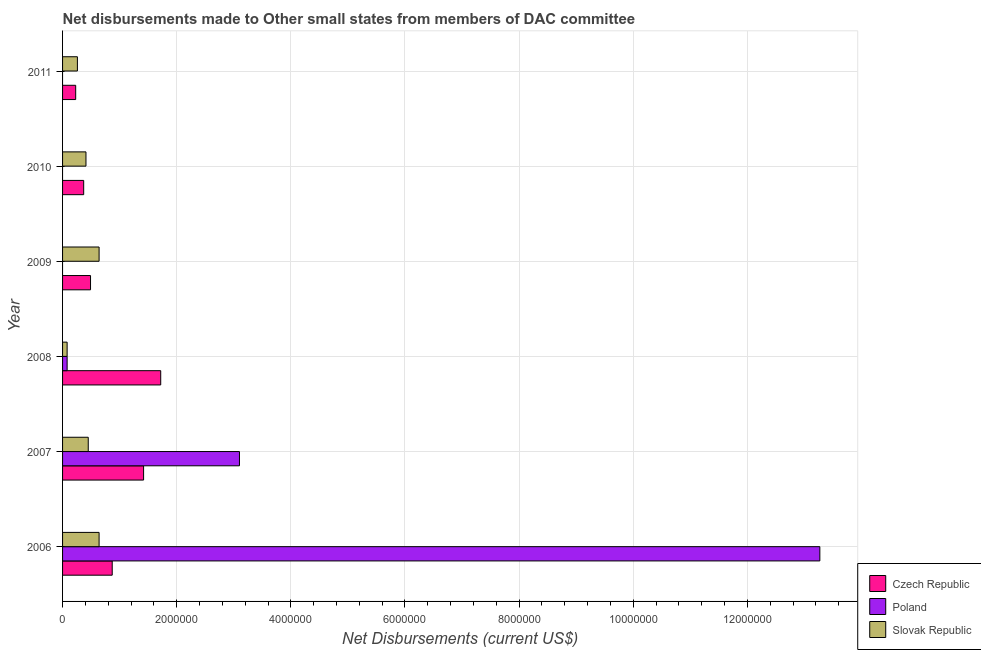How many different coloured bars are there?
Your answer should be compact. 3. Are the number of bars per tick equal to the number of legend labels?
Provide a succinct answer. No. Are the number of bars on each tick of the Y-axis equal?
Keep it short and to the point. No. What is the label of the 2nd group of bars from the top?
Give a very brief answer. 2010. In how many cases, is the number of bars for a given year not equal to the number of legend labels?
Your answer should be compact. 3. What is the net disbursements made by slovak republic in 2010?
Your answer should be compact. 4.10e+05. Across all years, what is the maximum net disbursements made by czech republic?
Give a very brief answer. 1.72e+06. Across all years, what is the minimum net disbursements made by slovak republic?
Provide a short and direct response. 8.00e+04. What is the total net disbursements made by czech republic in the graph?
Your response must be concise. 5.10e+06. What is the difference between the net disbursements made by slovak republic in 2008 and that in 2010?
Offer a very short reply. -3.30e+05. What is the difference between the net disbursements made by czech republic in 2010 and the net disbursements made by poland in 2009?
Your response must be concise. 3.70e+05. What is the average net disbursements made by poland per year?
Make the answer very short. 2.74e+06. In the year 2009, what is the difference between the net disbursements made by slovak republic and net disbursements made by czech republic?
Ensure brevity in your answer.  1.50e+05. In how many years, is the net disbursements made by slovak republic greater than 8800000 US$?
Offer a very short reply. 0. What is the ratio of the net disbursements made by czech republic in 2006 to that in 2011?
Offer a terse response. 3.78. What is the difference between the highest and the second highest net disbursements made by czech republic?
Your answer should be very brief. 3.00e+05. What is the difference between the highest and the lowest net disbursements made by czech republic?
Your answer should be compact. 1.49e+06. Is the sum of the net disbursements made by czech republic in 2007 and 2008 greater than the maximum net disbursements made by poland across all years?
Ensure brevity in your answer.  No. How many bars are there?
Provide a succinct answer. 15. Are all the bars in the graph horizontal?
Make the answer very short. Yes. How many years are there in the graph?
Give a very brief answer. 6. What is the difference between two consecutive major ticks on the X-axis?
Your response must be concise. 2.00e+06. Does the graph contain any zero values?
Offer a terse response. Yes. Does the graph contain grids?
Your answer should be very brief. Yes. How many legend labels are there?
Make the answer very short. 3. How are the legend labels stacked?
Provide a short and direct response. Vertical. What is the title of the graph?
Your answer should be very brief. Net disbursements made to Other small states from members of DAC committee. What is the label or title of the X-axis?
Keep it short and to the point. Net Disbursements (current US$). What is the Net Disbursements (current US$) of Czech Republic in 2006?
Your response must be concise. 8.70e+05. What is the Net Disbursements (current US$) of Poland in 2006?
Provide a succinct answer. 1.33e+07. What is the Net Disbursements (current US$) of Slovak Republic in 2006?
Make the answer very short. 6.40e+05. What is the Net Disbursements (current US$) of Czech Republic in 2007?
Provide a short and direct response. 1.42e+06. What is the Net Disbursements (current US$) of Poland in 2007?
Make the answer very short. 3.10e+06. What is the Net Disbursements (current US$) in Czech Republic in 2008?
Offer a very short reply. 1.72e+06. What is the Net Disbursements (current US$) of Czech Republic in 2009?
Give a very brief answer. 4.90e+05. What is the Net Disbursements (current US$) in Slovak Republic in 2009?
Offer a very short reply. 6.40e+05. What is the Net Disbursements (current US$) of Poland in 2010?
Offer a terse response. 0. What is the Net Disbursements (current US$) of Slovak Republic in 2010?
Offer a terse response. 4.10e+05. What is the Net Disbursements (current US$) of Czech Republic in 2011?
Give a very brief answer. 2.30e+05. Across all years, what is the maximum Net Disbursements (current US$) of Czech Republic?
Your answer should be compact. 1.72e+06. Across all years, what is the maximum Net Disbursements (current US$) in Poland?
Ensure brevity in your answer.  1.33e+07. Across all years, what is the maximum Net Disbursements (current US$) in Slovak Republic?
Keep it short and to the point. 6.40e+05. Across all years, what is the minimum Net Disbursements (current US$) of Czech Republic?
Offer a very short reply. 2.30e+05. What is the total Net Disbursements (current US$) of Czech Republic in the graph?
Your answer should be very brief. 5.10e+06. What is the total Net Disbursements (current US$) in Poland in the graph?
Offer a very short reply. 1.64e+07. What is the total Net Disbursements (current US$) of Slovak Republic in the graph?
Your answer should be very brief. 2.48e+06. What is the difference between the Net Disbursements (current US$) of Czech Republic in 2006 and that in 2007?
Ensure brevity in your answer.  -5.50e+05. What is the difference between the Net Disbursements (current US$) of Poland in 2006 and that in 2007?
Your answer should be compact. 1.02e+07. What is the difference between the Net Disbursements (current US$) in Slovak Republic in 2006 and that in 2007?
Offer a terse response. 1.90e+05. What is the difference between the Net Disbursements (current US$) in Czech Republic in 2006 and that in 2008?
Provide a short and direct response. -8.50e+05. What is the difference between the Net Disbursements (current US$) of Poland in 2006 and that in 2008?
Keep it short and to the point. 1.32e+07. What is the difference between the Net Disbursements (current US$) of Slovak Republic in 2006 and that in 2008?
Offer a terse response. 5.60e+05. What is the difference between the Net Disbursements (current US$) in Czech Republic in 2006 and that in 2009?
Keep it short and to the point. 3.80e+05. What is the difference between the Net Disbursements (current US$) of Slovak Republic in 2006 and that in 2009?
Make the answer very short. 0. What is the difference between the Net Disbursements (current US$) in Czech Republic in 2006 and that in 2011?
Give a very brief answer. 6.40e+05. What is the difference between the Net Disbursements (current US$) of Slovak Republic in 2006 and that in 2011?
Your answer should be compact. 3.80e+05. What is the difference between the Net Disbursements (current US$) in Czech Republic in 2007 and that in 2008?
Offer a terse response. -3.00e+05. What is the difference between the Net Disbursements (current US$) in Poland in 2007 and that in 2008?
Provide a short and direct response. 3.02e+06. What is the difference between the Net Disbursements (current US$) of Czech Republic in 2007 and that in 2009?
Ensure brevity in your answer.  9.30e+05. What is the difference between the Net Disbursements (current US$) in Slovak Republic in 2007 and that in 2009?
Offer a very short reply. -1.90e+05. What is the difference between the Net Disbursements (current US$) in Czech Republic in 2007 and that in 2010?
Offer a terse response. 1.05e+06. What is the difference between the Net Disbursements (current US$) of Slovak Republic in 2007 and that in 2010?
Your response must be concise. 4.00e+04. What is the difference between the Net Disbursements (current US$) in Czech Republic in 2007 and that in 2011?
Keep it short and to the point. 1.19e+06. What is the difference between the Net Disbursements (current US$) in Czech Republic in 2008 and that in 2009?
Keep it short and to the point. 1.23e+06. What is the difference between the Net Disbursements (current US$) of Slovak Republic in 2008 and that in 2009?
Offer a very short reply. -5.60e+05. What is the difference between the Net Disbursements (current US$) of Czech Republic in 2008 and that in 2010?
Your answer should be compact. 1.35e+06. What is the difference between the Net Disbursements (current US$) of Slovak Republic in 2008 and that in 2010?
Offer a very short reply. -3.30e+05. What is the difference between the Net Disbursements (current US$) of Czech Republic in 2008 and that in 2011?
Give a very brief answer. 1.49e+06. What is the difference between the Net Disbursements (current US$) of Czech Republic in 2009 and that in 2010?
Provide a short and direct response. 1.20e+05. What is the difference between the Net Disbursements (current US$) of Slovak Republic in 2009 and that in 2010?
Your answer should be very brief. 2.30e+05. What is the difference between the Net Disbursements (current US$) in Czech Republic in 2009 and that in 2011?
Your answer should be very brief. 2.60e+05. What is the difference between the Net Disbursements (current US$) in Slovak Republic in 2009 and that in 2011?
Your response must be concise. 3.80e+05. What is the difference between the Net Disbursements (current US$) of Czech Republic in 2010 and that in 2011?
Provide a short and direct response. 1.40e+05. What is the difference between the Net Disbursements (current US$) in Czech Republic in 2006 and the Net Disbursements (current US$) in Poland in 2007?
Offer a very short reply. -2.23e+06. What is the difference between the Net Disbursements (current US$) of Czech Republic in 2006 and the Net Disbursements (current US$) of Slovak Republic in 2007?
Ensure brevity in your answer.  4.20e+05. What is the difference between the Net Disbursements (current US$) of Poland in 2006 and the Net Disbursements (current US$) of Slovak Republic in 2007?
Give a very brief answer. 1.28e+07. What is the difference between the Net Disbursements (current US$) of Czech Republic in 2006 and the Net Disbursements (current US$) of Poland in 2008?
Provide a short and direct response. 7.90e+05. What is the difference between the Net Disbursements (current US$) of Czech Republic in 2006 and the Net Disbursements (current US$) of Slovak Republic in 2008?
Ensure brevity in your answer.  7.90e+05. What is the difference between the Net Disbursements (current US$) in Poland in 2006 and the Net Disbursements (current US$) in Slovak Republic in 2008?
Provide a short and direct response. 1.32e+07. What is the difference between the Net Disbursements (current US$) of Czech Republic in 2006 and the Net Disbursements (current US$) of Slovak Republic in 2009?
Your answer should be very brief. 2.30e+05. What is the difference between the Net Disbursements (current US$) of Poland in 2006 and the Net Disbursements (current US$) of Slovak Republic in 2009?
Keep it short and to the point. 1.26e+07. What is the difference between the Net Disbursements (current US$) in Czech Republic in 2006 and the Net Disbursements (current US$) in Slovak Republic in 2010?
Make the answer very short. 4.60e+05. What is the difference between the Net Disbursements (current US$) of Poland in 2006 and the Net Disbursements (current US$) of Slovak Republic in 2010?
Make the answer very short. 1.29e+07. What is the difference between the Net Disbursements (current US$) of Poland in 2006 and the Net Disbursements (current US$) of Slovak Republic in 2011?
Your response must be concise. 1.30e+07. What is the difference between the Net Disbursements (current US$) in Czech Republic in 2007 and the Net Disbursements (current US$) in Poland in 2008?
Offer a very short reply. 1.34e+06. What is the difference between the Net Disbursements (current US$) in Czech Republic in 2007 and the Net Disbursements (current US$) in Slovak Republic in 2008?
Offer a terse response. 1.34e+06. What is the difference between the Net Disbursements (current US$) of Poland in 2007 and the Net Disbursements (current US$) of Slovak Republic in 2008?
Make the answer very short. 3.02e+06. What is the difference between the Net Disbursements (current US$) of Czech Republic in 2007 and the Net Disbursements (current US$) of Slovak Republic in 2009?
Offer a very short reply. 7.80e+05. What is the difference between the Net Disbursements (current US$) of Poland in 2007 and the Net Disbursements (current US$) of Slovak Republic in 2009?
Give a very brief answer. 2.46e+06. What is the difference between the Net Disbursements (current US$) in Czech Republic in 2007 and the Net Disbursements (current US$) in Slovak Republic in 2010?
Provide a succinct answer. 1.01e+06. What is the difference between the Net Disbursements (current US$) in Poland in 2007 and the Net Disbursements (current US$) in Slovak Republic in 2010?
Offer a terse response. 2.69e+06. What is the difference between the Net Disbursements (current US$) in Czech Republic in 2007 and the Net Disbursements (current US$) in Slovak Republic in 2011?
Ensure brevity in your answer.  1.16e+06. What is the difference between the Net Disbursements (current US$) in Poland in 2007 and the Net Disbursements (current US$) in Slovak Republic in 2011?
Offer a very short reply. 2.84e+06. What is the difference between the Net Disbursements (current US$) of Czech Republic in 2008 and the Net Disbursements (current US$) of Slovak Republic in 2009?
Ensure brevity in your answer.  1.08e+06. What is the difference between the Net Disbursements (current US$) in Poland in 2008 and the Net Disbursements (current US$) in Slovak Republic in 2009?
Your answer should be very brief. -5.60e+05. What is the difference between the Net Disbursements (current US$) of Czech Republic in 2008 and the Net Disbursements (current US$) of Slovak Republic in 2010?
Offer a terse response. 1.31e+06. What is the difference between the Net Disbursements (current US$) in Poland in 2008 and the Net Disbursements (current US$) in Slovak Republic in 2010?
Your answer should be compact. -3.30e+05. What is the difference between the Net Disbursements (current US$) in Czech Republic in 2008 and the Net Disbursements (current US$) in Slovak Republic in 2011?
Offer a terse response. 1.46e+06. What is the difference between the Net Disbursements (current US$) of Poland in 2008 and the Net Disbursements (current US$) of Slovak Republic in 2011?
Offer a very short reply. -1.80e+05. What is the difference between the Net Disbursements (current US$) of Czech Republic in 2009 and the Net Disbursements (current US$) of Slovak Republic in 2010?
Offer a very short reply. 8.00e+04. What is the average Net Disbursements (current US$) in Czech Republic per year?
Offer a very short reply. 8.50e+05. What is the average Net Disbursements (current US$) of Poland per year?
Offer a terse response. 2.74e+06. What is the average Net Disbursements (current US$) of Slovak Republic per year?
Your answer should be compact. 4.13e+05. In the year 2006, what is the difference between the Net Disbursements (current US$) in Czech Republic and Net Disbursements (current US$) in Poland?
Your response must be concise. -1.24e+07. In the year 2006, what is the difference between the Net Disbursements (current US$) in Czech Republic and Net Disbursements (current US$) in Slovak Republic?
Offer a very short reply. 2.30e+05. In the year 2006, what is the difference between the Net Disbursements (current US$) in Poland and Net Disbursements (current US$) in Slovak Republic?
Your answer should be very brief. 1.26e+07. In the year 2007, what is the difference between the Net Disbursements (current US$) in Czech Republic and Net Disbursements (current US$) in Poland?
Provide a succinct answer. -1.68e+06. In the year 2007, what is the difference between the Net Disbursements (current US$) of Czech Republic and Net Disbursements (current US$) of Slovak Republic?
Ensure brevity in your answer.  9.70e+05. In the year 2007, what is the difference between the Net Disbursements (current US$) in Poland and Net Disbursements (current US$) in Slovak Republic?
Provide a short and direct response. 2.65e+06. In the year 2008, what is the difference between the Net Disbursements (current US$) in Czech Republic and Net Disbursements (current US$) in Poland?
Offer a very short reply. 1.64e+06. In the year 2008, what is the difference between the Net Disbursements (current US$) in Czech Republic and Net Disbursements (current US$) in Slovak Republic?
Keep it short and to the point. 1.64e+06. In the year 2009, what is the difference between the Net Disbursements (current US$) of Czech Republic and Net Disbursements (current US$) of Slovak Republic?
Your answer should be very brief. -1.50e+05. In the year 2011, what is the difference between the Net Disbursements (current US$) in Czech Republic and Net Disbursements (current US$) in Slovak Republic?
Your response must be concise. -3.00e+04. What is the ratio of the Net Disbursements (current US$) of Czech Republic in 2006 to that in 2007?
Your answer should be compact. 0.61. What is the ratio of the Net Disbursements (current US$) of Poland in 2006 to that in 2007?
Your response must be concise. 4.28. What is the ratio of the Net Disbursements (current US$) of Slovak Republic in 2006 to that in 2007?
Make the answer very short. 1.42. What is the ratio of the Net Disbursements (current US$) of Czech Republic in 2006 to that in 2008?
Provide a succinct answer. 0.51. What is the ratio of the Net Disbursements (current US$) in Poland in 2006 to that in 2008?
Your response must be concise. 165.88. What is the ratio of the Net Disbursements (current US$) in Slovak Republic in 2006 to that in 2008?
Provide a succinct answer. 8. What is the ratio of the Net Disbursements (current US$) in Czech Republic in 2006 to that in 2009?
Provide a succinct answer. 1.78. What is the ratio of the Net Disbursements (current US$) of Slovak Republic in 2006 to that in 2009?
Provide a short and direct response. 1. What is the ratio of the Net Disbursements (current US$) of Czech Republic in 2006 to that in 2010?
Offer a very short reply. 2.35. What is the ratio of the Net Disbursements (current US$) in Slovak Republic in 2006 to that in 2010?
Your response must be concise. 1.56. What is the ratio of the Net Disbursements (current US$) in Czech Republic in 2006 to that in 2011?
Give a very brief answer. 3.78. What is the ratio of the Net Disbursements (current US$) in Slovak Republic in 2006 to that in 2011?
Your answer should be compact. 2.46. What is the ratio of the Net Disbursements (current US$) of Czech Republic in 2007 to that in 2008?
Provide a succinct answer. 0.83. What is the ratio of the Net Disbursements (current US$) in Poland in 2007 to that in 2008?
Your answer should be very brief. 38.75. What is the ratio of the Net Disbursements (current US$) of Slovak Republic in 2007 to that in 2008?
Your response must be concise. 5.62. What is the ratio of the Net Disbursements (current US$) of Czech Republic in 2007 to that in 2009?
Offer a terse response. 2.9. What is the ratio of the Net Disbursements (current US$) of Slovak Republic in 2007 to that in 2009?
Keep it short and to the point. 0.7. What is the ratio of the Net Disbursements (current US$) of Czech Republic in 2007 to that in 2010?
Your answer should be very brief. 3.84. What is the ratio of the Net Disbursements (current US$) in Slovak Republic in 2007 to that in 2010?
Provide a short and direct response. 1.1. What is the ratio of the Net Disbursements (current US$) of Czech Republic in 2007 to that in 2011?
Provide a succinct answer. 6.17. What is the ratio of the Net Disbursements (current US$) in Slovak Republic in 2007 to that in 2011?
Provide a short and direct response. 1.73. What is the ratio of the Net Disbursements (current US$) in Czech Republic in 2008 to that in 2009?
Your response must be concise. 3.51. What is the ratio of the Net Disbursements (current US$) of Slovak Republic in 2008 to that in 2009?
Your answer should be very brief. 0.12. What is the ratio of the Net Disbursements (current US$) of Czech Republic in 2008 to that in 2010?
Keep it short and to the point. 4.65. What is the ratio of the Net Disbursements (current US$) of Slovak Republic in 2008 to that in 2010?
Your answer should be very brief. 0.2. What is the ratio of the Net Disbursements (current US$) of Czech Republic in 2008 to that in 2011?
Your response must be concise. 7.48. What is the ratio of the Net Disbursements (current US$) of Slovak Republic in 2008 to that in 2011?
Offer a very short reply. 0.31. What is the ratio of the Net Disbursements (current US$) in Czech Republic in 2009 to that in 2010?
Keep it short and to the point. 1.32. What is the ratio of the Net Disbursements (current US$) of Slovak Republic in 2009 to that in 2010?
Provide a short and direct response. 1.56. What is the ratio of the Net Disbursements (current US$) of Czech Republic in 2009 to that in 2011?
Your answer should be very brief. 2.13. What is the ratio of the Net Disbursements (current US$) of Slovak Republic in 2009 to that in 2011?
Keep it short and to the point. 2.46. What is the ratio of the Net Disbursements (current US$) in Czech Republic in 2010 to that in 2011?
Provide a succinct answer. 1.61. What is the ratio of the Net Disbursements (current US$) of Slovak Republic in 2010 to that in 2011?
Provide a short and direct response. 1.58. What is the difference between the highest and the second highest Net Disbursements (current US$) in Poland?
Your answer should be compact. 1.02e+07. What is the difference between the highest and the second highest Net Disbursements (current US$) of Slovak Republic?
Your response must be concise. 0. What is the difference between the highest and the lowest Net Disbursements (current US$) in Czech Republic?
Offer a very short reply. 1.49e+06. What is the difference between the highest and the lowest Net Disbursements (current US$) in Poland?
Your answer should be very brief. 1.33e+07. What is the difference between the highest and the lowest Net Disbursements (current US$) in Slovak Republic?
Ensure brevity in your answer.  5.60e+05. 